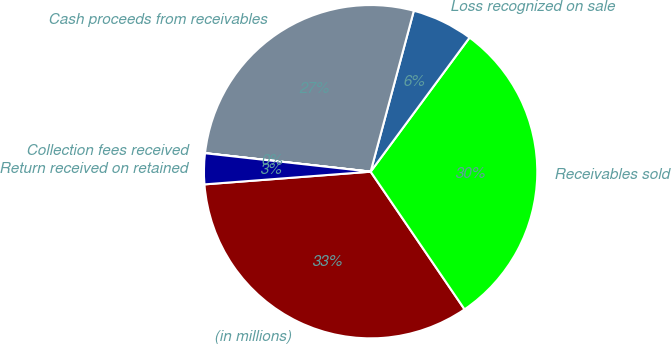<chart> <loc_0><loc_0><loc_500><loc_500><pie_chart><fcel>(in millions)<fcel>Receivables sold<fcel>Loss recognized on sale<fcel>Cash proceeds from receivables<fcel>Collection fees received<fcel>Return received on retained<nl><fcel>33.32%<fcel>30.36%<fcel>5.94%<fcel>27.4%<fcel>0.01%<fcel>2.98%<nl></chart> 